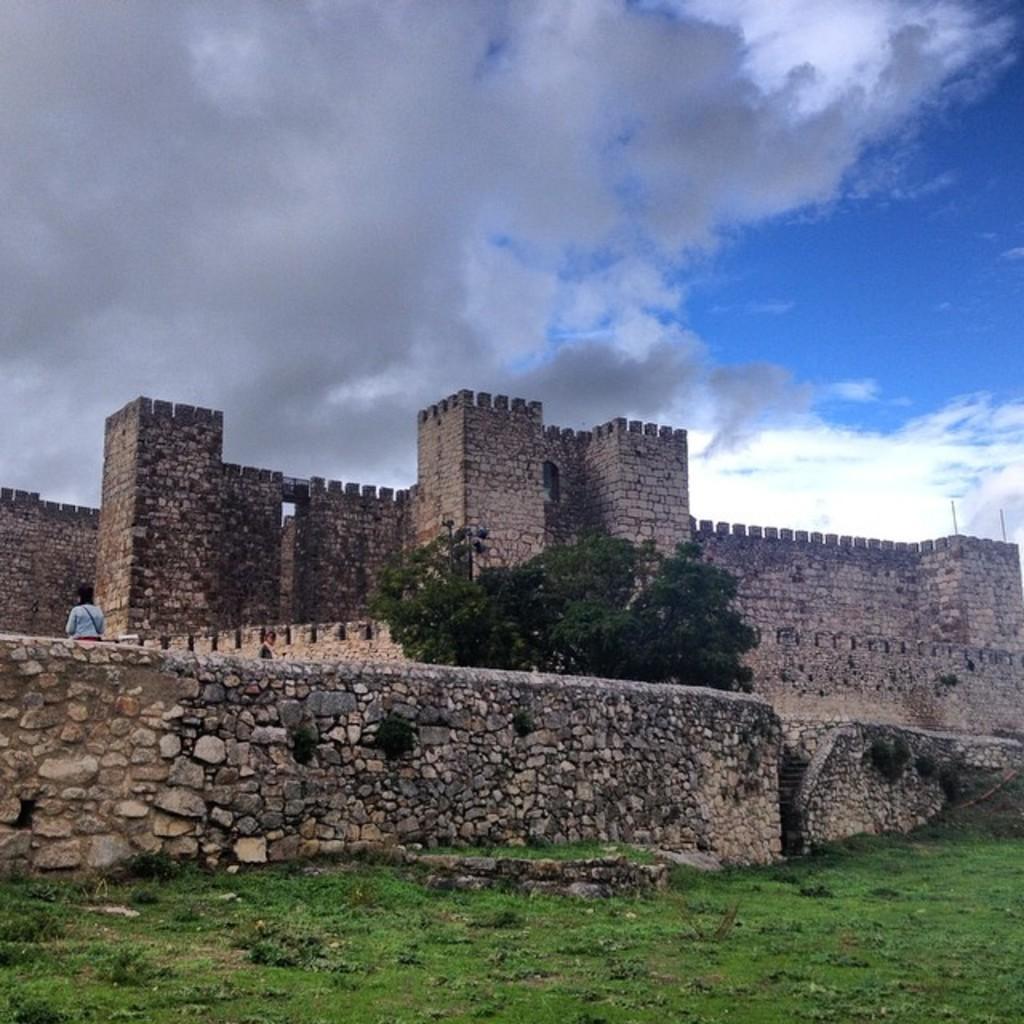In one or two sentences, can you explain what this image depicts? In this image I can see the fort in brown and black color. In front I can see a person wearing white color shirt, trees in green color and the sky is in blue and white color. 